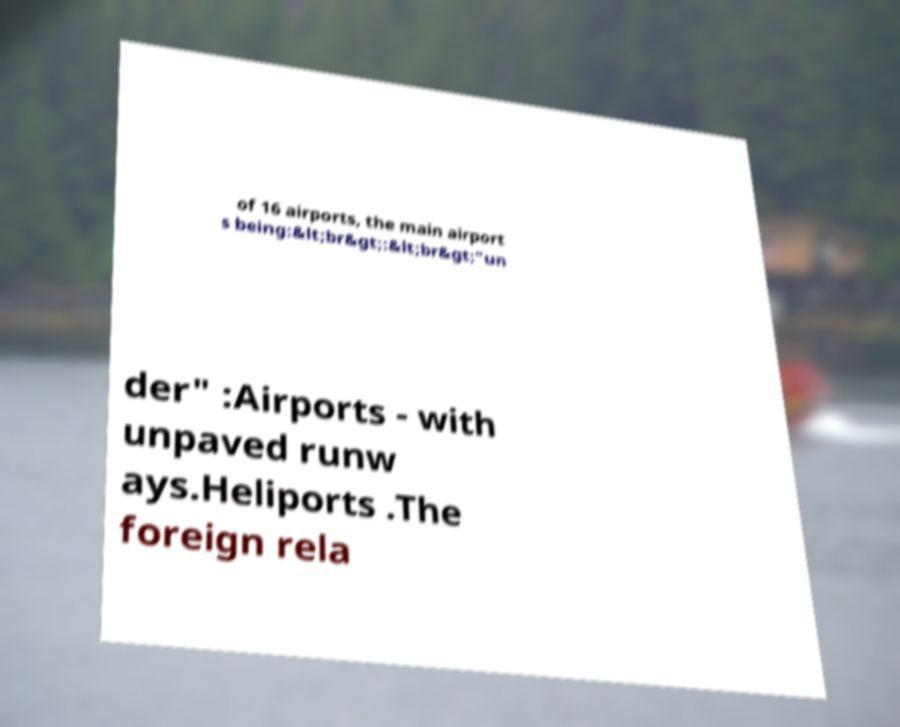Please identify and transcribe the text found in this image. of 16 airports, the main airport s being:&lt;br&gt;:&lt;br&gt;"un der" :Airports - with unpaved runw ays.Heliports .The foreign rela 